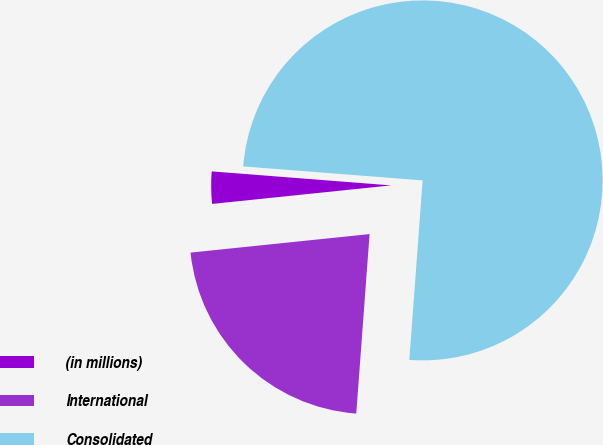Convert chart to OTSL. <chart><loc_0><loc_0><loc_500><loc_500><pie_chart><fcel>(in millions)<fcel>International<fcel>Consolidated<nl><fcel>2.88%<fcel>22.18%<fcel>74.94%<nl></chart> 